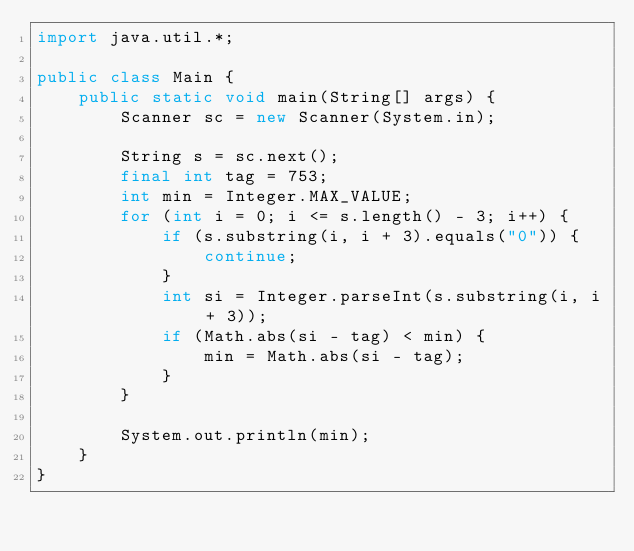Convert code to text. <code><loc_0><loc_0><loc_500><loc_500><_Java_>import java.util.*;

public class Main {
    public static void main(String[] args) {
        Scanner sc = new Scanner(System.in);

        String s = sc.next();
        final int tag = 753;
        int min = Integer.MAX_VALUE;
        for (int i = 0; i <= s.length() - 3; i++) {
            if (s.substring(i, i + 3).equals("0")) {
                continue;
            }
            int si = Integer.parseInt(s.substring(i, i + 3));
            if (Math.abs(si - tag) < min) {
                min = Math.abs(si - tag);
            }
        }

        System.out.println(min);
    }
}</code> 